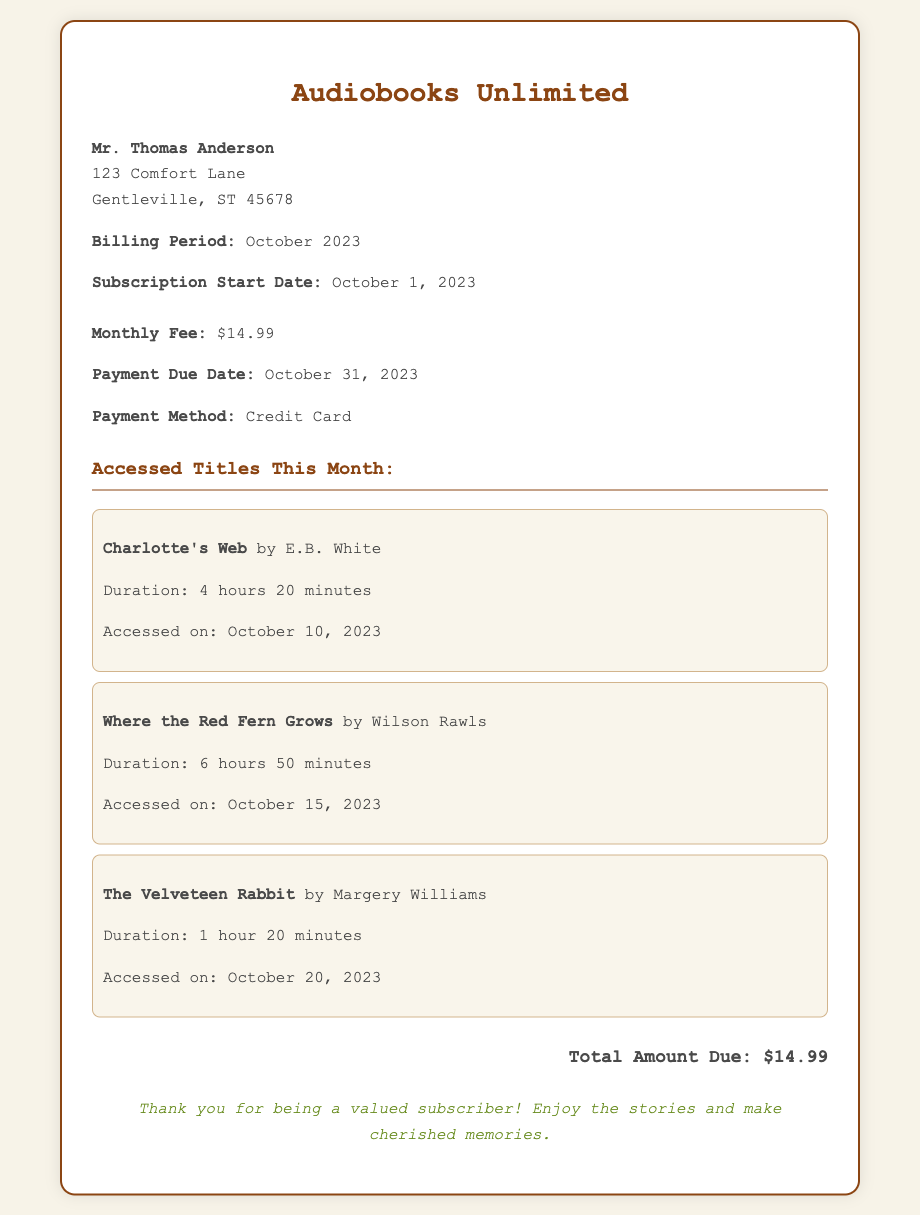What is the monthly fee? The monthly fee is stated in the subscription details section of the bill.
Answer: $14.99 Who is the bill addressed to? The customer's name is given in the customer info section of the bill.
Answer: Mr. Thomas Anderson When is the payment due? The due date for payment is mentioned in the subscription details section.
Answer: October 31, 2023 How many titles were accessed this month? The number of titles accessed is indicated in the accessed titles section of the bill.
Answer: 3 What is the title of the first audiobook accessed? The title of the first audiobook is mentioned in the accessed titles section.
Answer: Charlotte's Web Which payment method is used? The payment method is specified in the subscription details section of the bill.
Answer: Credit Card What is the total amount due? The total amount due is provided at the end of the bill.
Answer: $14.99 How long is the audiobook "Where the Red Fern Grows"? The duration of the audiobook is detailed in the accessed titles section.
Answer: 6 hours 50 minutes When was "The Velveteen Rabbit" accessed? The access date for "The Velveteen Rabbit" is stated in the accessed titles section.
Answer: October 20, 2023 